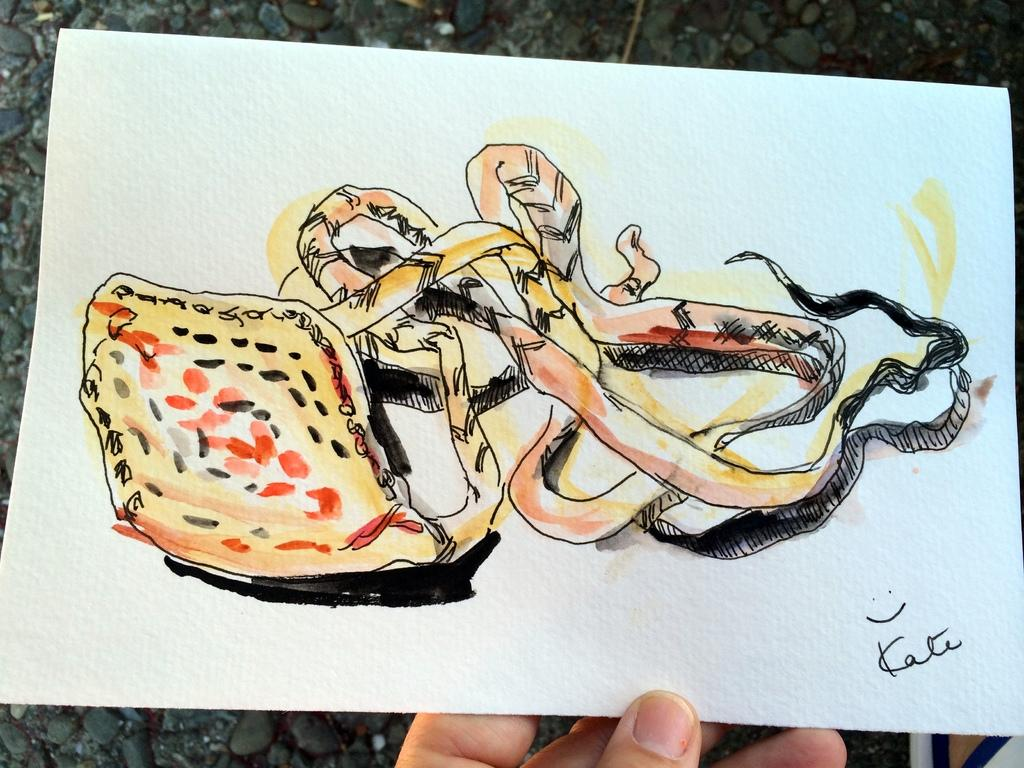What is the person holding in the image? The person is holding a painting paper in the image. Can you describe any additional details about the painting paper? Yes, there is a signature on the painting paper. Where is the nest located in the image? There is no nest present in the image. What type of land can be seen in the image? The image does not depict any land; it only shows a person holding a painting paper with a signature. 